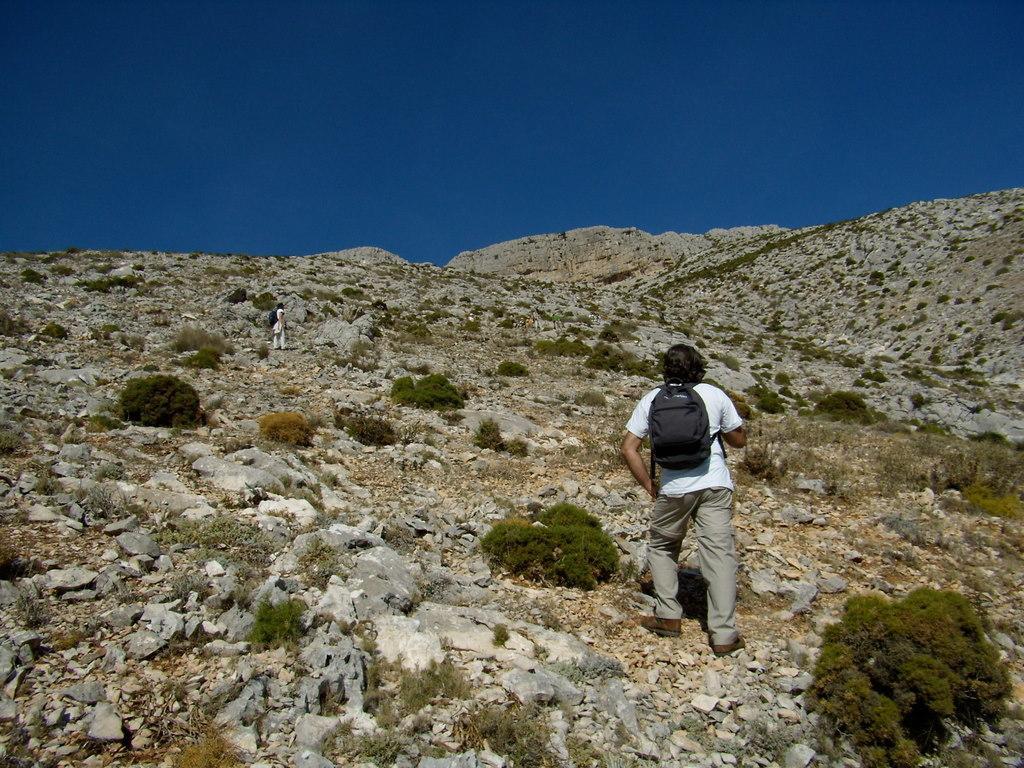Describe this image in one or two sentences. This is the picture of a mountain. In this image there are two persons standing on the mountain and there are plants on the mountain. At the top there is sky. 